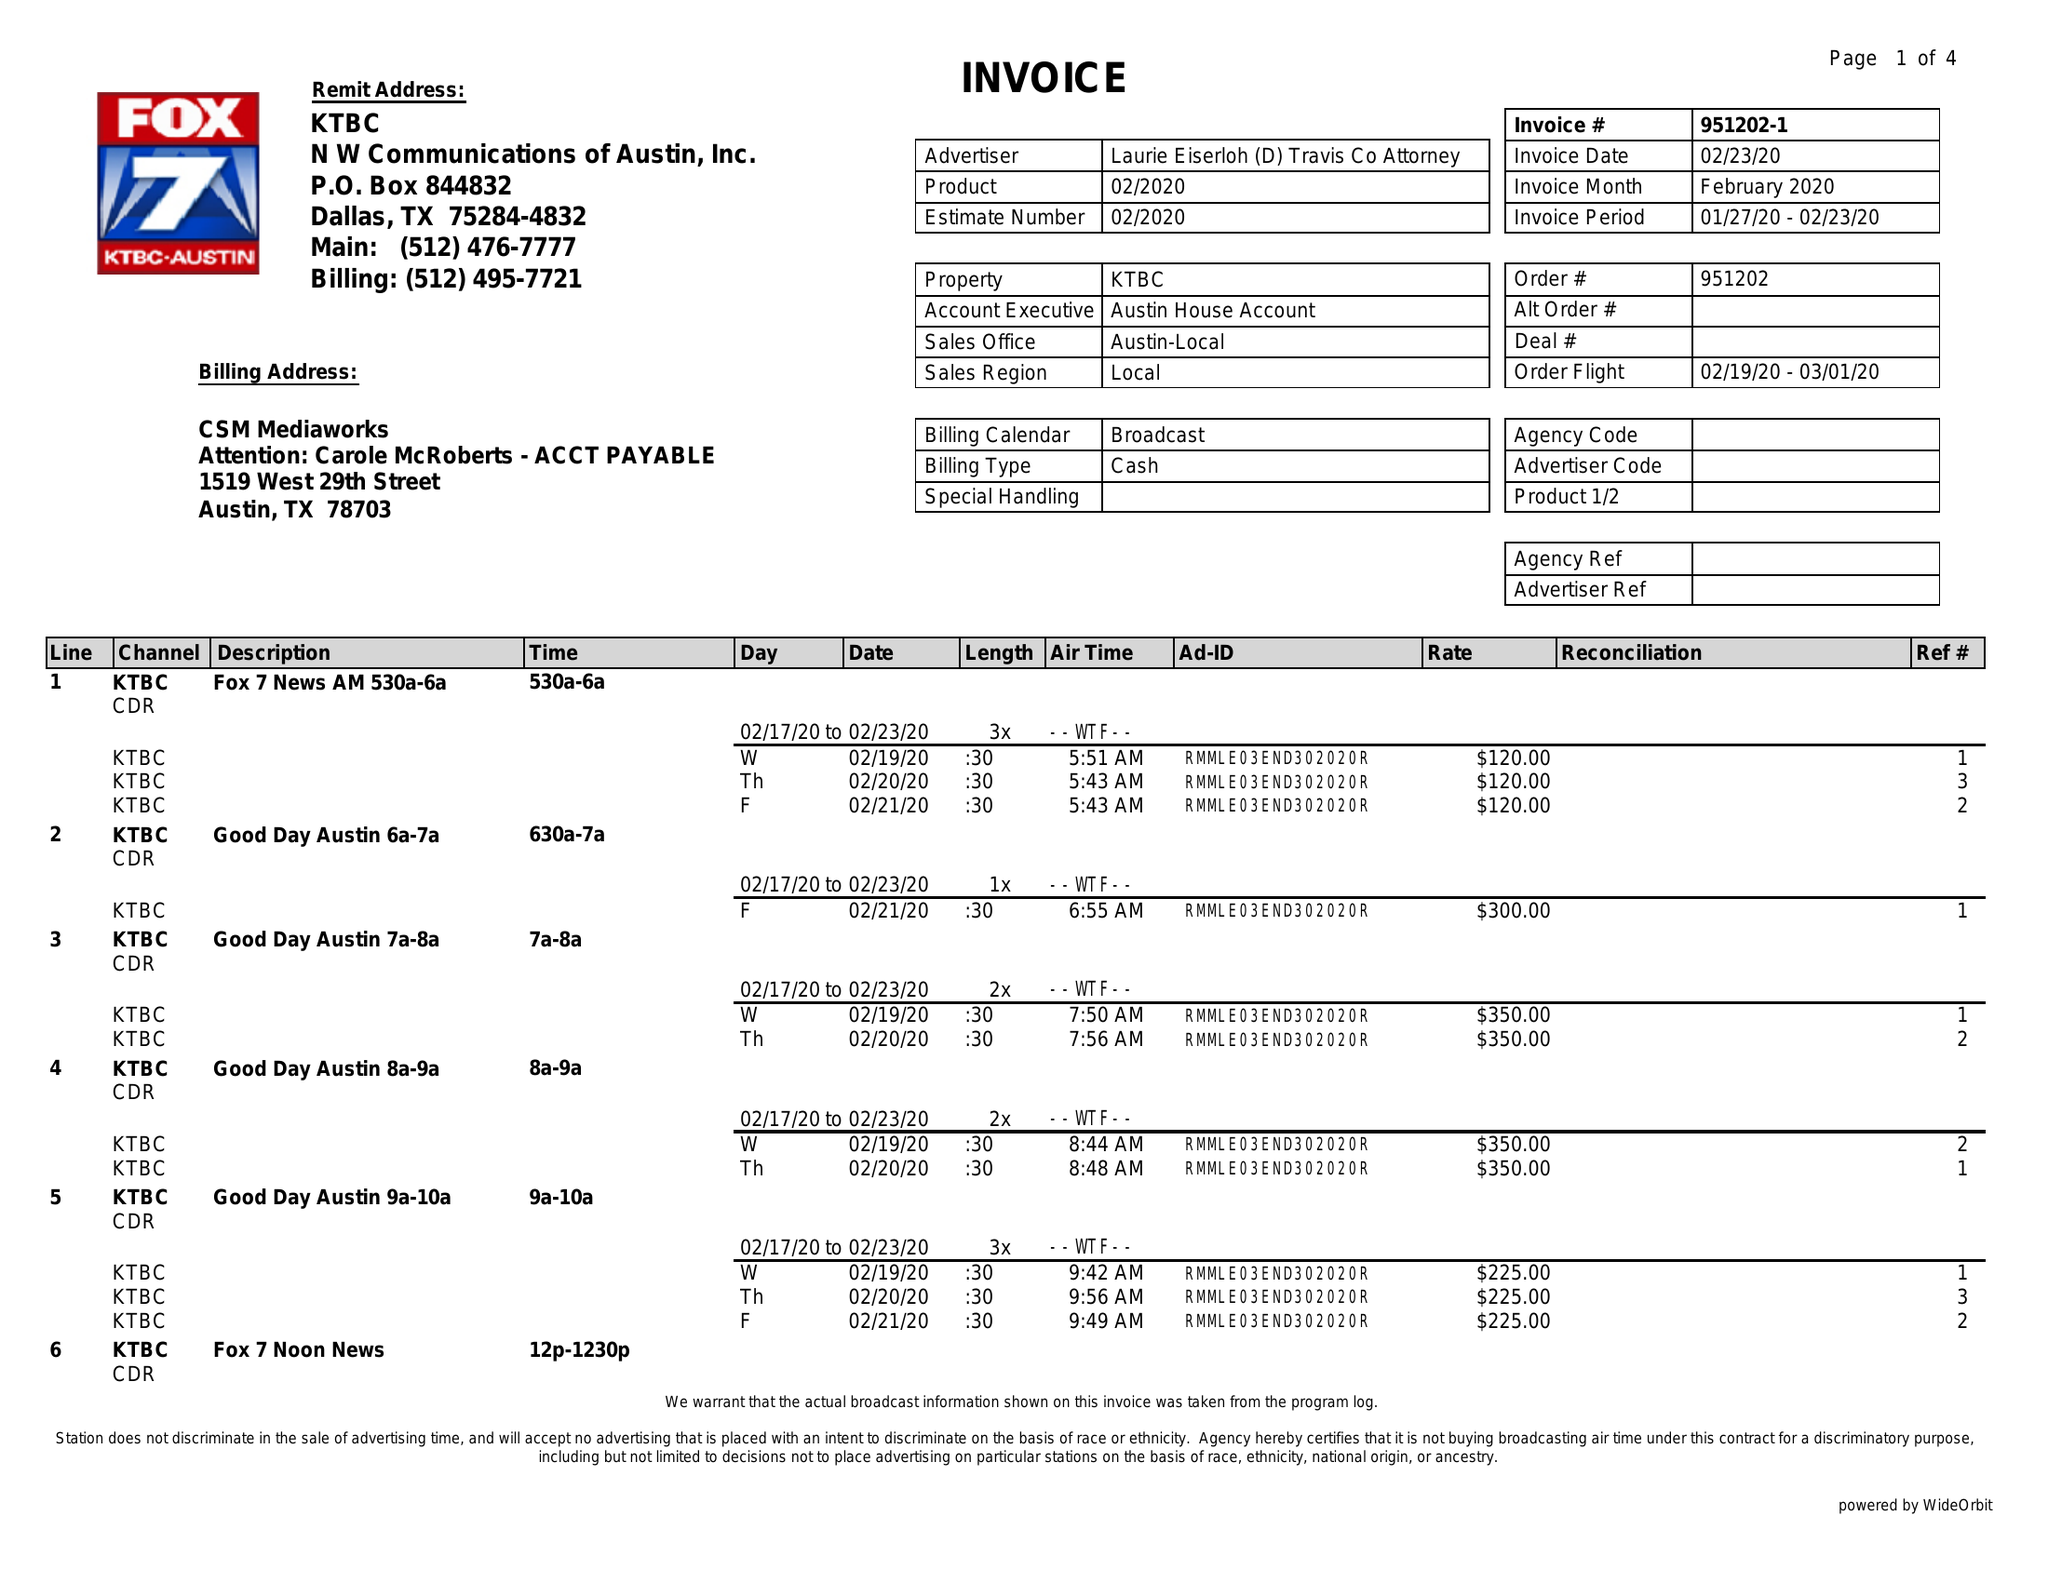What is the value for the gross_amount?
Answer the question using a single word or phrase. 5715.00 